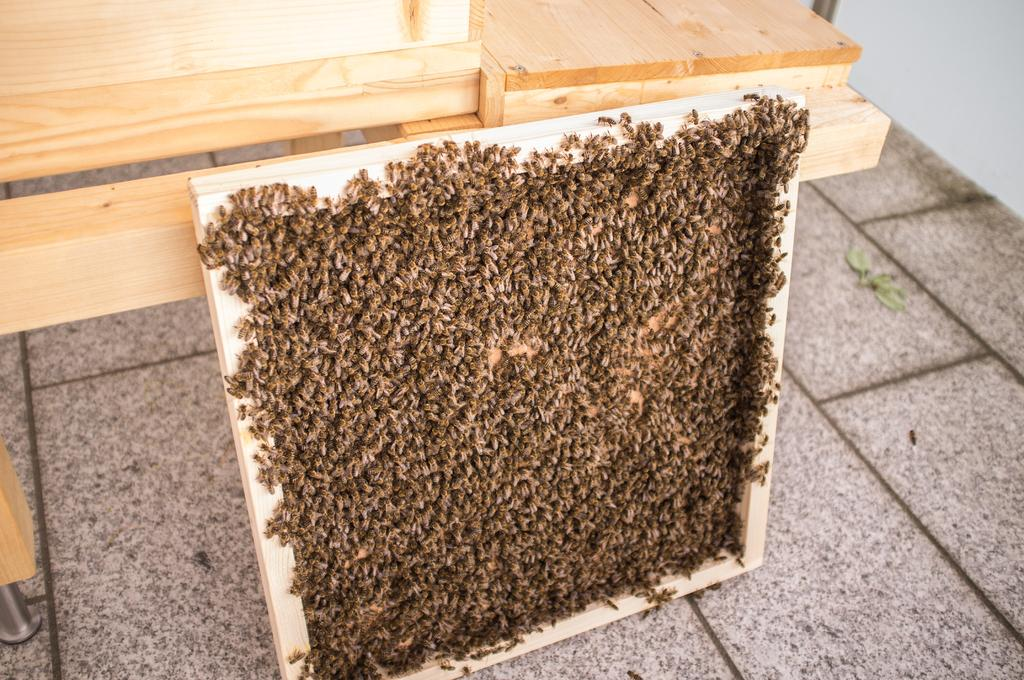What insects can be seen in the image? There are bees on the honeycomb in the image. What type of structure is visible in the background? There is a wooden stand in the background of the image. What surface is visible at the bottom of the image? There is a floor visible at the bottom of the image. How does the temper of the bees change throughout the day in the image? The image does not provide information about the temper of the bees or how it changes throughout the day. --- 